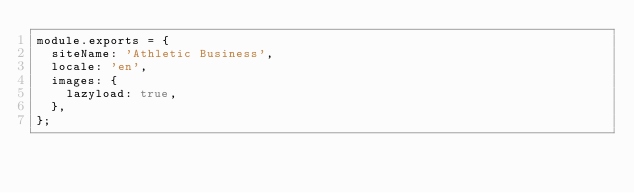<code> <loc_0><loc_0><loc_500><loc_500><_JavaScript_>module.exports = {
  siteName: 'Athletic Business',
  locale: 'en',
  images: {
    lazyload: true,
  },
};
</code> 